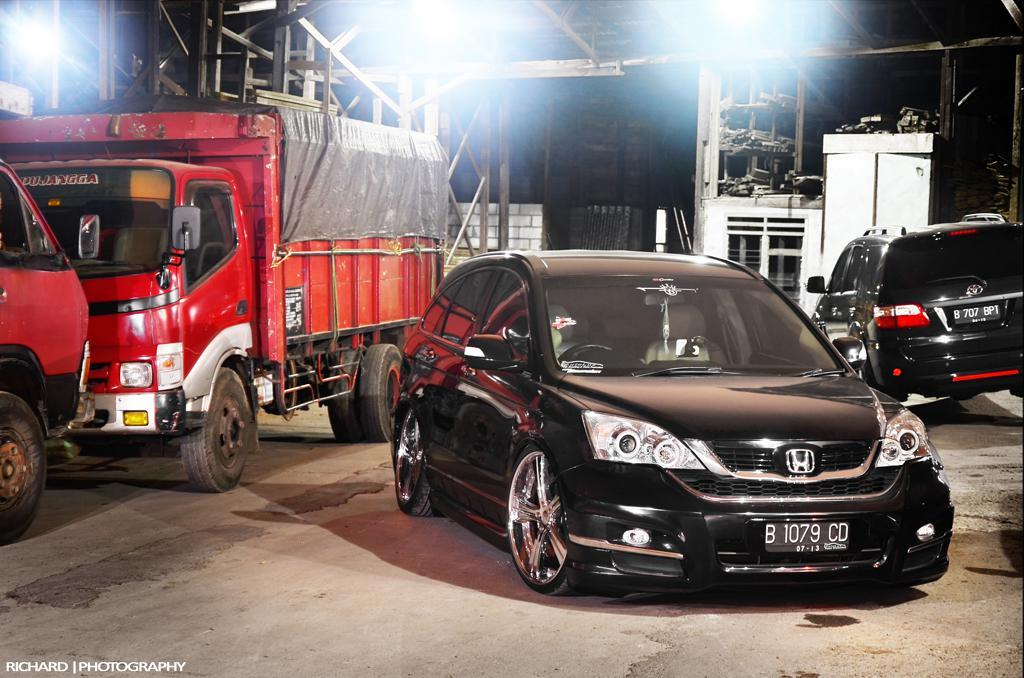What is located in the center of the image? There are vehicles in the center of the image. What can be seen in the background of the image? There is a wall, a transformer, and rods in the background of the image. What is at the bottom of the image? There is a road at the bottom of the image. Is there any text present in the image? Yes, there is some text at the bottom of the image. Where is the sofa placed in the image? There is no sofa present in the image. What type of vase can be seen on the wall in the image? There is no vase present on the wall in the image. 